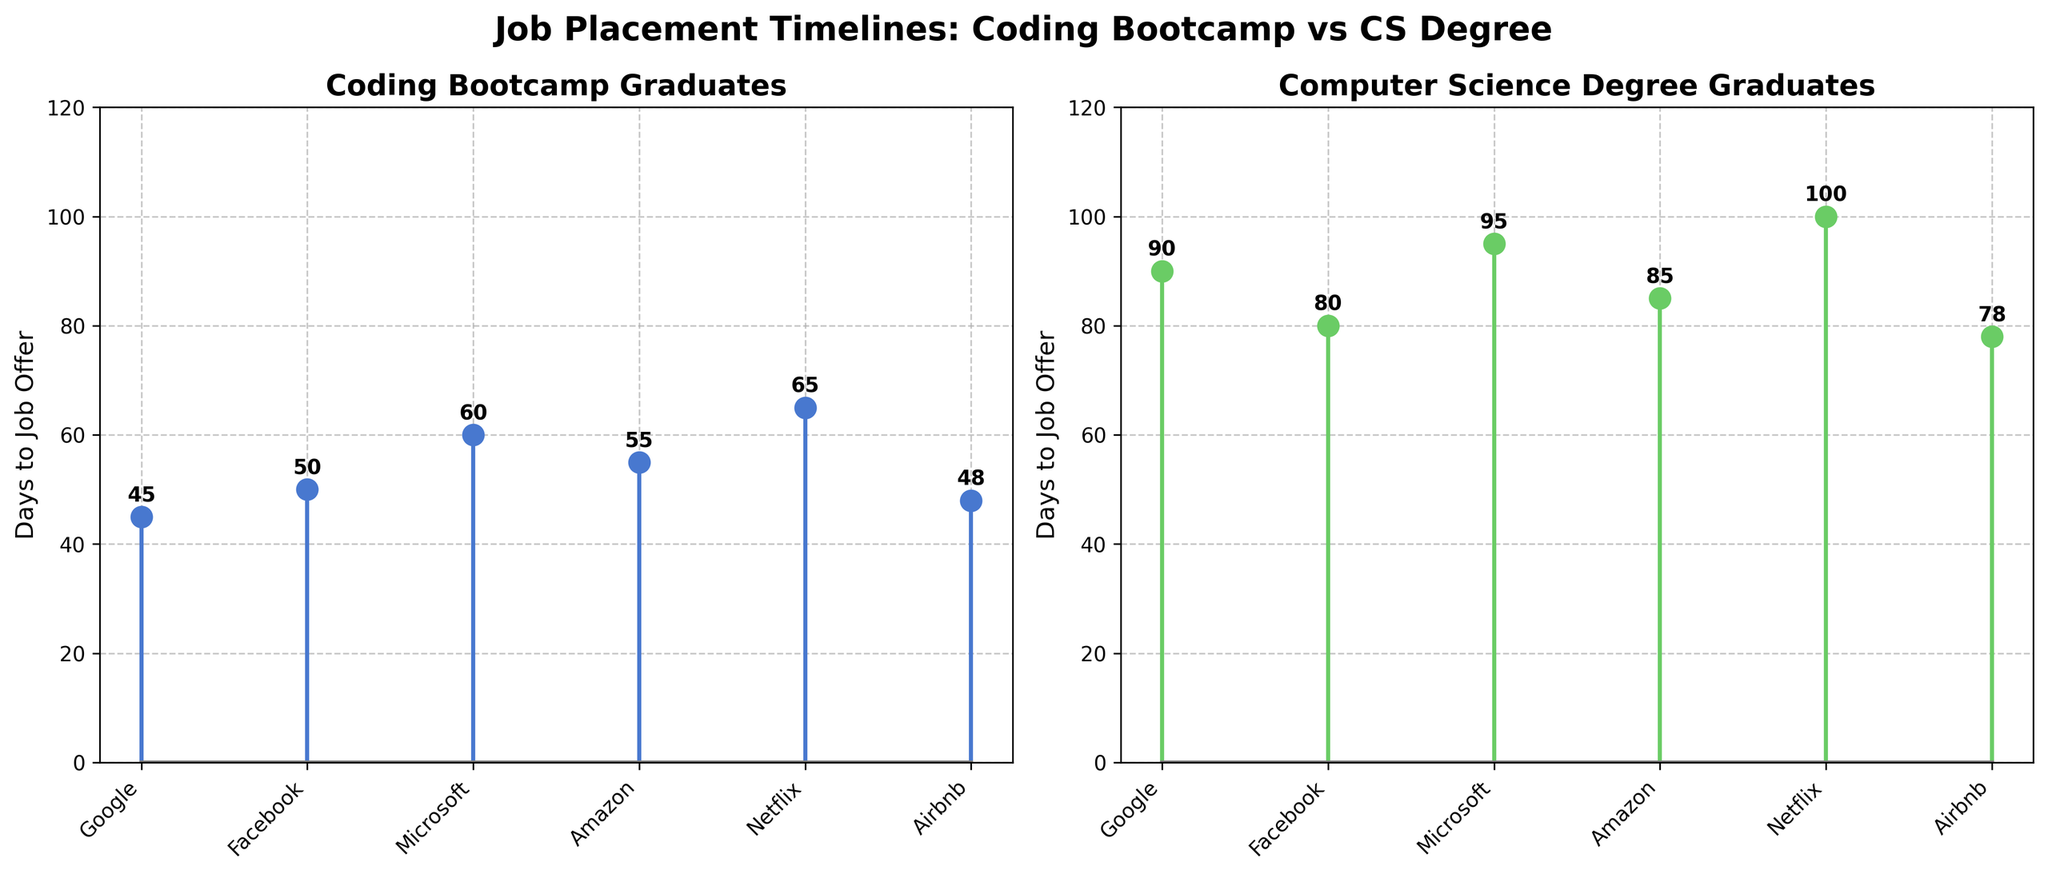What's the title of the plot? The title of the plot is displayed prominently at the top of the figure.
Answer: Job Placement Timelines: Coding Bootcamp vs CS Degree How many data points are there for each type of graduate? By counting the number of markers on each subplot, we observe there are 6 data points for each type of graduate.
Answer: 6 What is the company with the shortest job placement timeline for coding bootcamp graduates? By observing the values on the y-axis within the first subplot, the point with the lowest value indicates the shortest timeline, which is Airbnb at 48 days.
Answer: Airbnb What is the average number of days to a job offer for coding bootcamp graduates? Adding up all the days for the coding bootcamp graduates (45 + 50 + 60 + 55 + 65 + 48) and then dividing by the number of data points (6) gives the average. (45+50+60+55+65+48)/6 = 53.83 days.
Answer: 53.83 days Which company offered jobs quicker to coding bootcamp graduates as compared to computer science degree graduates? By comparing days to a job offer between the two subplots for each company, the easier comparisons indicate: Google, Facebook, Amazon, Netflix, and Airbnb.
Answer: Google, Facebook, Amazon, Netflix, Airbnb For which company is the gap in job placement timelines the largest between coding bootcamp graduates and computer science degree graduates? Calculating the absolute difference in days to a job for each company, we find the maximum difference. Netflix gap is 100 - 65 = 35 days.
Answer: Netflix Which type of graduates, on average, received job offers quicker? Calculate the average for both types and compare: Coding Bootcamp (45+50+60+55+65+48)/6 = 53.83 days. Computer Science Degree (90+80+95+85+100+78)/6 = 88 days.
Answer: Coding Bootcamp graduates What is the median job offer timeline for coding bootcamp graduates? Arrange the days for coding bootcamp (45, 48, 50, 55, 60, 65) and the median value (middle value) would be (50+55)/2 = 52.5 days.
Answer: 52.5 days Is there a consistent trend in job placement timelines among different companies for the same graduate type? By observing the distribution of the days on each subplot, we notice there is no clear trend as the days fluctuate for both types of graduates.
Answer: No 